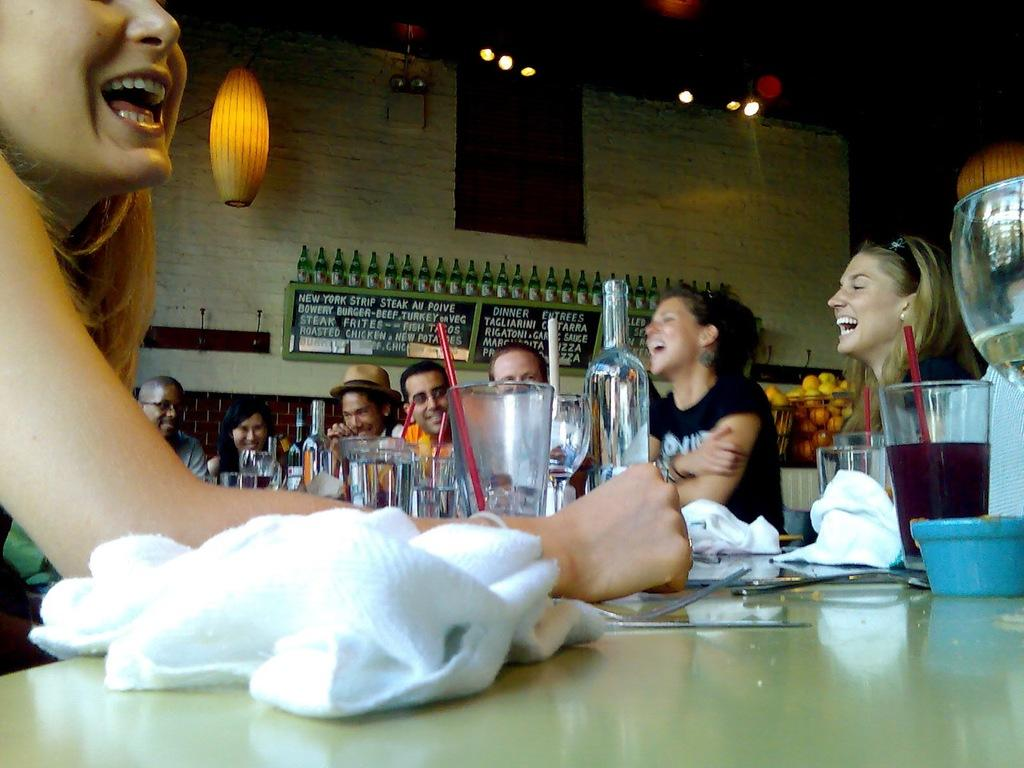How many people are in the image? There is a group of people in the image. What are the people doing in the image? The people are sitting on chairs. How are the chairs arranged in the image? The chairs are arranged around a table. What can be seen on the table in the image? There are glasses and napkins on the table. What is visible in the background of the image? There is a wall in the background of the image. What is the current relationship between the boys and their father in the image? There are no boys or father mentioned in the image; it only features a group of people sitting around a table. 